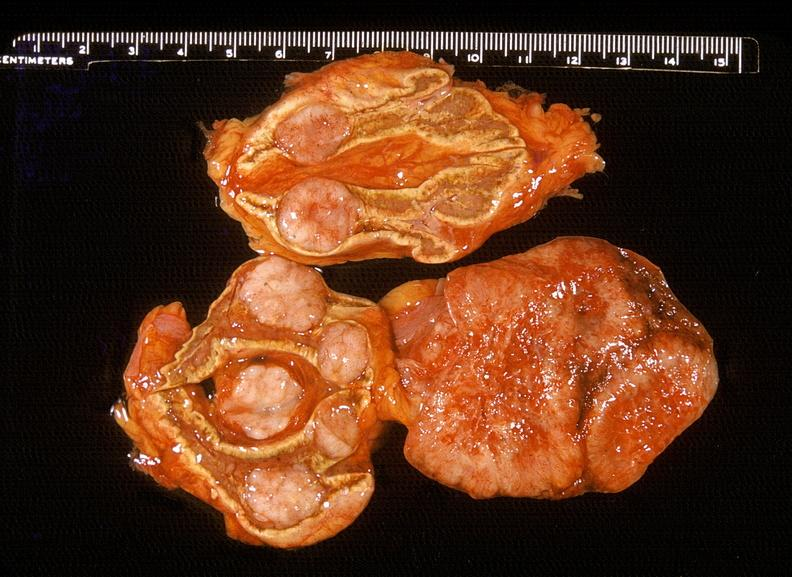s abdomen present?
Answer the question using a single word or phrase. No 